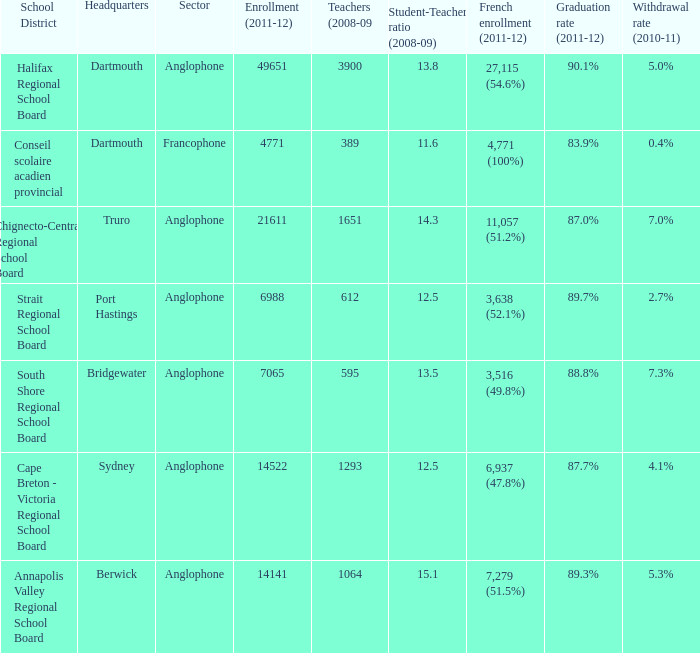What is the withdrawal rate for the school district with a graduation rate of 89.3%? 5.3%. 